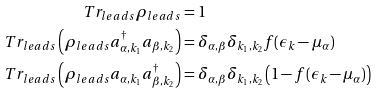<formula> <loc_0><loc_0><loc_500><loc_500>T r _ { l e a d s } { \rho _ { l e a d s } } & = 1 \\ T r _ { l e a d s } \left ( \rho _ { l e a d s } a _ { \alpha , k _ { 1 } } ^ { \dagger } a _ { \beta , k _ { 2 } } \right ) & = \delta _ { \alpha , \beta } \delta _ { k _ { 1 } , k _ { 2 } } f ( \epsilon _ { k } - \mu _ { \alpha } ) \\ T r _ { l e a d s } \left ( \rho _ { l e a d s } a _ { \alpha , k _ { 1 } } a _ { \beta , k _ { 2 } } ^ { \dagger } \right ) & = \delta _ { \alpha , \beta } \delta _ { k _ { 1 } , k _ { 2 } } \left ( 1 - f ( \epsilon _ { k } - \mu _ { \alpha } ) \right )</formula> 